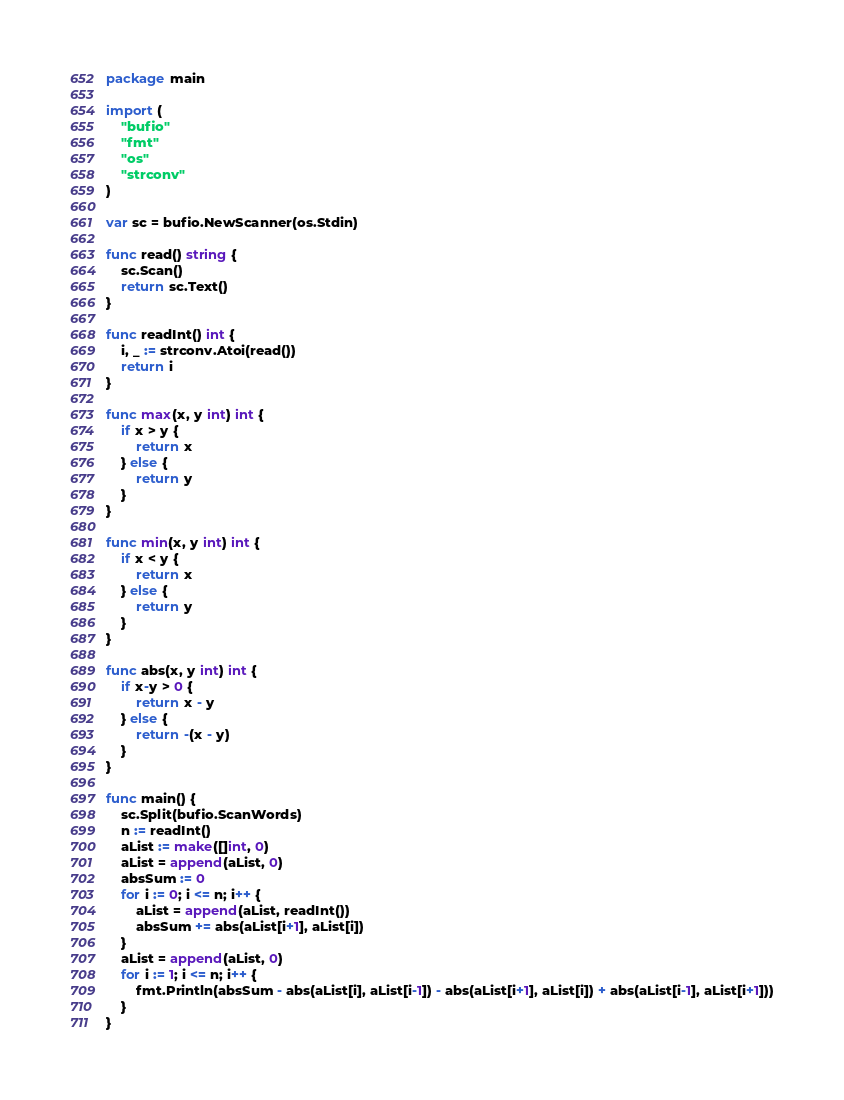<code> <loc_0><loc_0><loc_500><loc_500><_Go_>package main

import (
	"bufio"
	"fmt"
	"os"
	"strconv"
)

var sc = bufio.NewScanner(os.Stdin)

func read() string {
	sc.Scan()
	return sc.Text()
}

func readInt() int {
	i, _ := strconv.Atoi(read())
	return i
}

func max(x, y int) int {
	if x > y {
		return x
	} else {
		return y
	}
}

func min(x, y int) int {
	if x < y {
		return x
	} else {
		return y
	}
}

func abs(x, y int) int {
	if x-y > 0 {
		return x - y
	} else {
		return -(x - y)
	}
}

func main() {
	sc.Split(bufio.ScanWords)
	n := readInt()
	aList := make([]int, 0)
	aList = append(aList, 0)
	absSum := 0
	for i := 0; i <= n; i++ {
		aList = append(aList, readInt())
		absSum += abs(aList[i+1], aList[i])
	}
	aList = append(aList, 0)
	for i := 1; i <= n; i++ {
		fmt.Println(absSum - abs(aList[i], aList[i-1]) - abs(aList[i+1], aList[i]) + abs(aList[i-1], aList[i+1]))
	}
}
</code> 